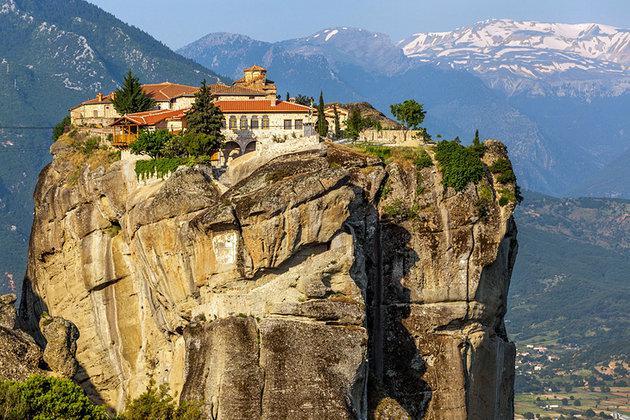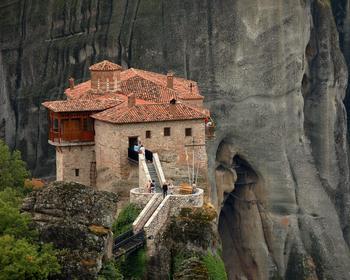The first image is the image on the left, the second image is the image on the right. Assess this claim about the two images: "There are stairs in the image on the right". Correct or not? Answer yes or no. Yes. 